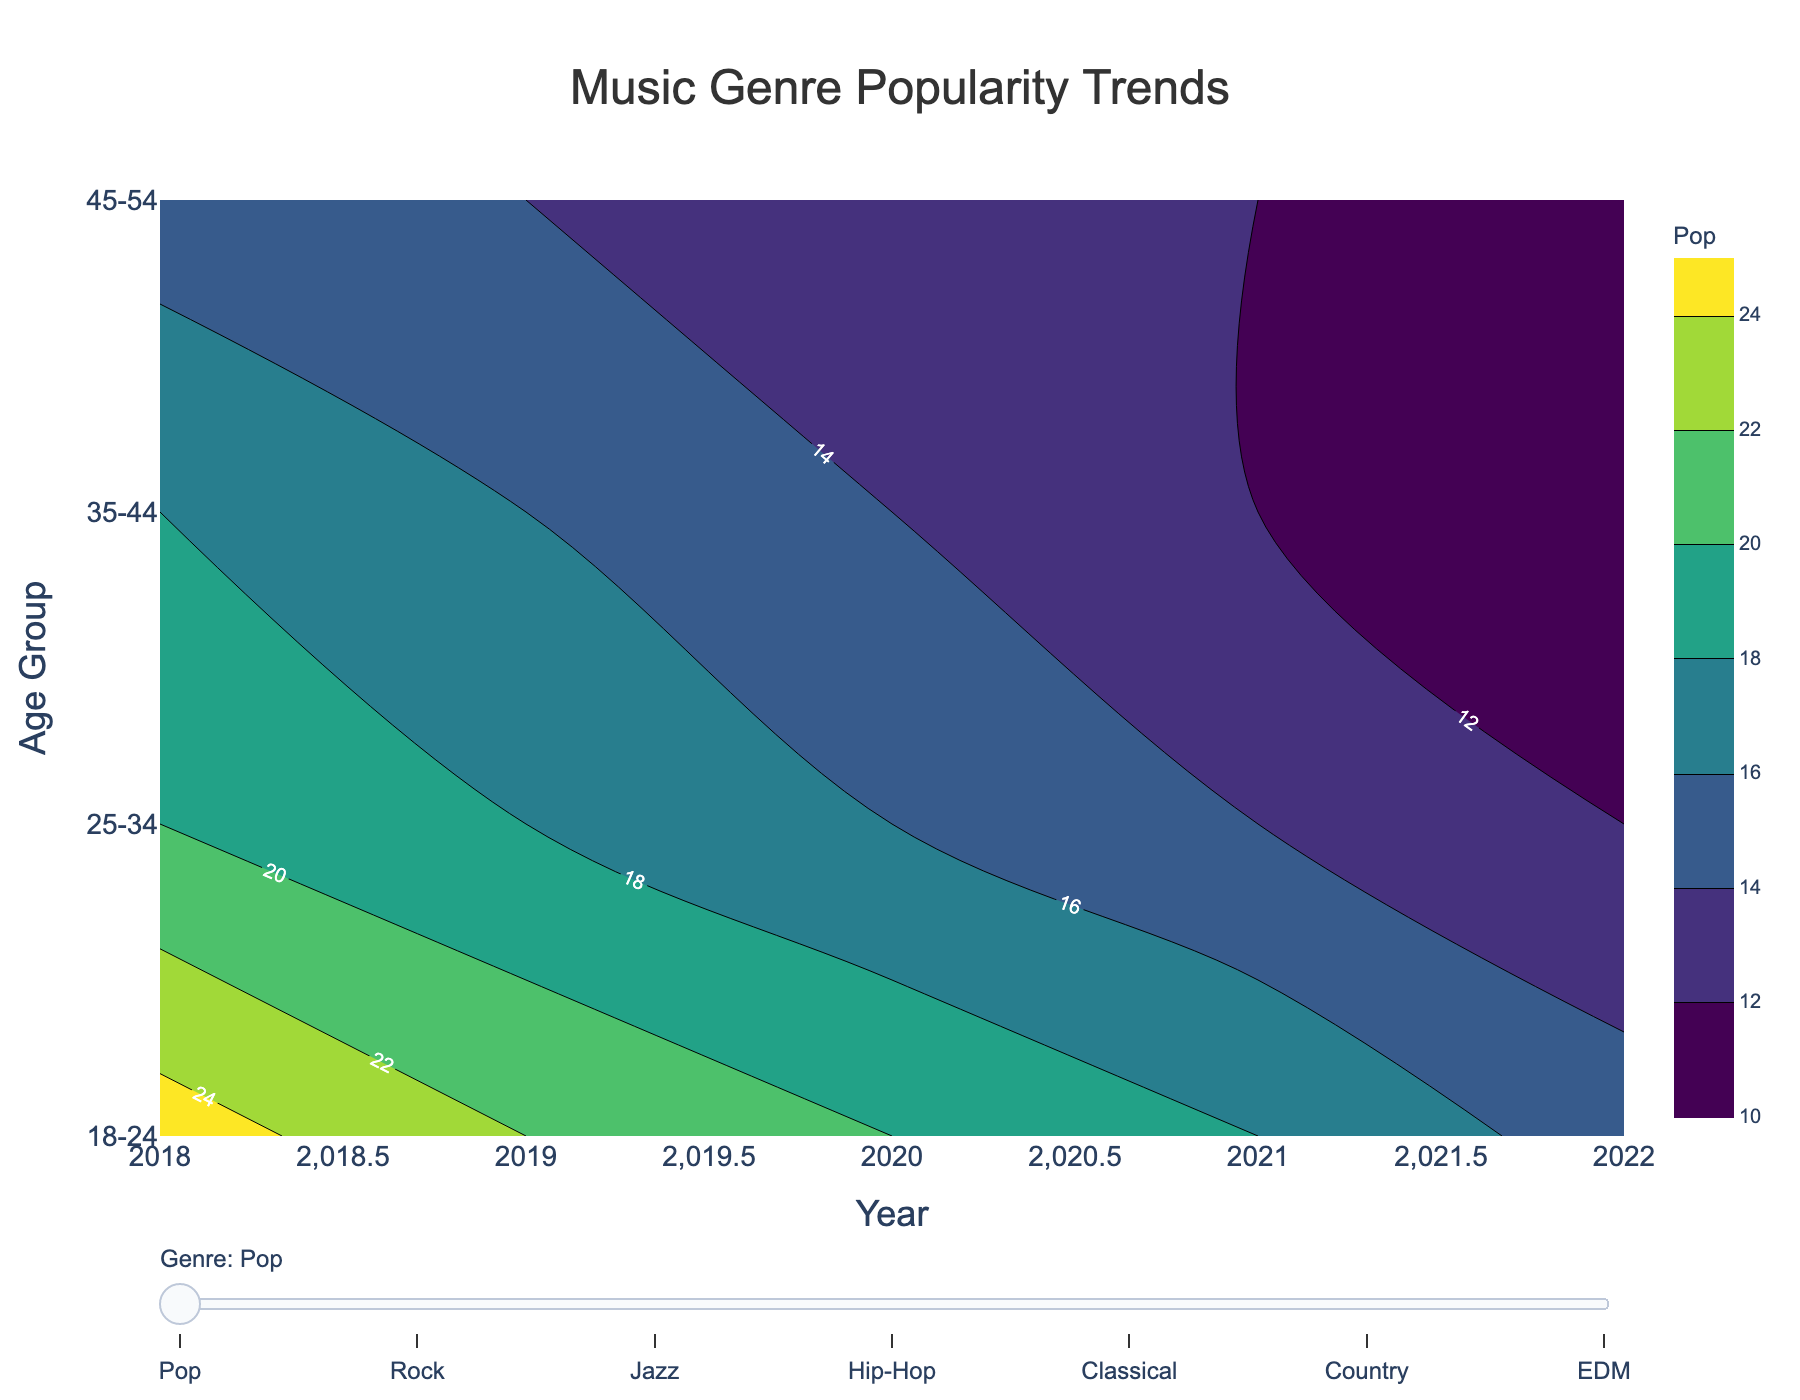What is the title of the plot? The title of the plot is displayed at the top center of the image and reads "Music Genre Popularity Trends."
Answer: Music Genre Popularity Trends Which age group showed an increasing trend in Hip-Hop popularity from 2018 to 2022? By examining the contours for Hip-Hop, the age group 18-24 shows a steady increase in Hip-Hop popularity over the years 2018 to 2022.
Answer: 18-24 In 2022, which age group had the highest popularity for Classical music? By looking at the contours for 2022 under the Classical music genre, age group 45-54 is positioned higher on the color gradient, indicating higher popularity.
Answer: 45-54 Which genre shows the most significant decline in popularity for the 18-24 age group from 2018 to 2022? By examining the contours for the 18-24 age group across different genres, Pop shows the most considerable decline, starting the highest in 2018 and decreasing steadily through to 2022.
Answer: Pop For the age group 25-34, what is the difference in Country music popularity between 2018 and 2022? Country music popularity for 25-34 is noted as 10 in 2018 and 13 in 2022. Subtracting the values gives the difference, 13 - 10 = 3.
Answer: 3 Between 35-44 and 45-54 age groups, which group had a higher average popularity in Jazz music over the years? Calculate the average for both groups by summing their Jazz popularity values over the years and dividing by the number of years. For 35-44: (15 + 14 + 13 + 12 + 10)/5 = 12.8. For 45-54: (18 + 17 + 16 + 15 + 14)/5 = 16. Thus, 45-54 has a higher average.
Answer: 45-54 Which genre has the most even distribution of popularity across all age groups in 2022? By comparing the 2022 contours across genres, EDM shows relatively balanced contour levels across all age groups.
Answer: EDM Was there any age group that consistently preferred EDM from 2018 to 2022? By examining the contours for EDM from 2018 to 2022, the age groups 25-34 and 35-44 consistently show interest without significant increases or decreases, indicating a preference.
Answer: 25-34 and 35-44 For the age group 18-24, which two genres had the closest popularity values in 2020? In 2020, for age group 18-24, the popularity values for Classical (6) and Country (6) are closest.
Answer: Classical and Country Was there any point where Rock was the most popular genre for the 35-44 age group? Yes, by examining the contours, in 2018, Rock is the most popular genre for the 35-44 age group.
Answer: 2018 